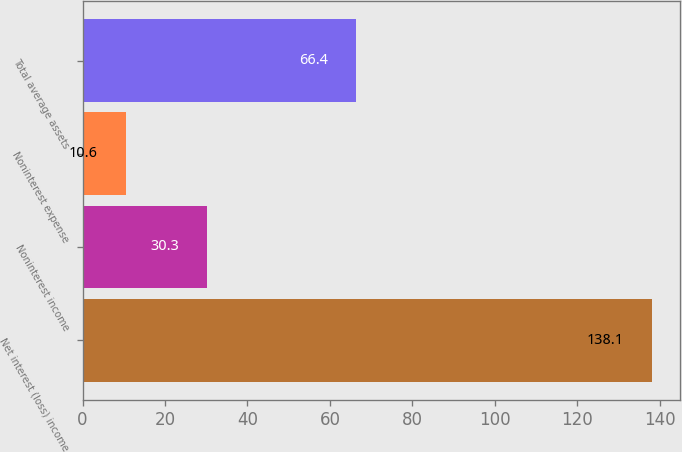Convert chart. <chart><loc_0><loc_0><loc_500><loc_500><bar_chart><fcel>Net interest (loss) income<fcel>Noninterest income<fcel>Noninterest expense<fcel>Total average assets<nl><fcel>138.1<fcel>30.3<fcel>10.6<fcel>66.4<nl></chart> 